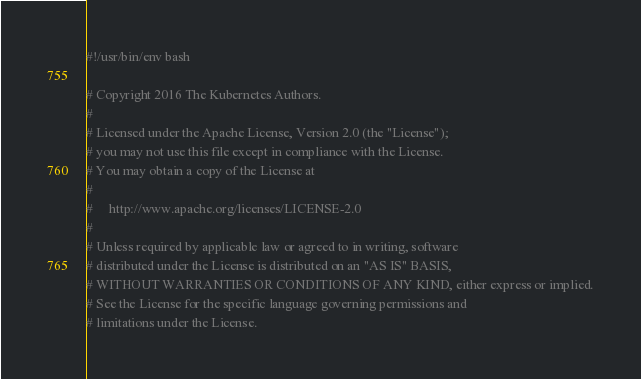<code> <loc_0><loc_0><loc_500><loc_500><_Bash_>#!/usr/bin/env bash

# Copyright 2016 The Kubernetes Authors.
#
# Licensed under the Apache License, Version 2.0 (the "License");
# you may not use this file except in compliance with the License.
# You may obtain a copy of the License at
#
#     http://www.apache.org/licenses/LICENSE-2.0
#
# Unless required by applicable law or agreed to in writing, software
# distributed under the License is distributed on an "AS IS" BASIS,
# WITHOUT WARRANTIES OR CONDITIONS OF ANY KIND, either express or implied.
# See the License for the specific language governing permissions and
# limitations under the License.
</code> 